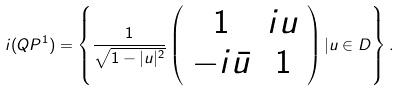Convert formula to latex. <formula><loc_0><loc_0><loc_500><loc_500>i ( Q P ^ { 1 } ) = \left \{ \frac { 1 } { \sqrt { 1 - | u | ^ { 2 } } } \left ( \begin{array} { c c } 1 & i u \\ - i \bar { u } & 1 \\ \end{array} \right ) | u \in D \right \} .</formula> 